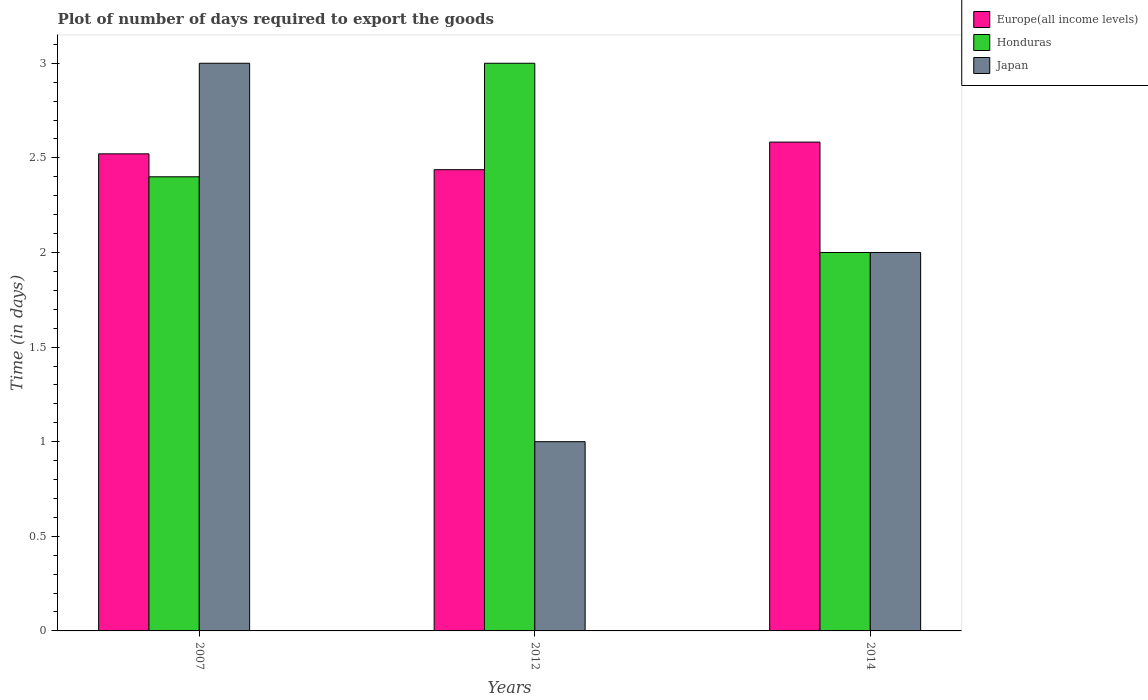How many different coloured bars are there?
Your response must be concise. 3. How many groups of bars are there?
Keep it short and to the point. 3. Are the number of bars per tick equal to the number of legend labels?
Your answer should be compact. Yes. How many bars are there on the 1st tick from the left?
Offer a very short reply. 3. How many bars are there on the 3rd tick from the right?
Offer a terse response. 3. What is the label of the 2nd group of bars from the left?
Offer a terse response. 2012. In how many cases, is the number of bars for a given year not equal to the number of legend labels?
Your answer should be compact. 0. What is the time required to export goods in Japan in 2007?
Offer a very short reply. 3. Across all years, what is the minimum time required to export goods in Japan?
Your answer should be very brief. 1. What is the total time required to export goods in Europe(all income levels) in the graph?
Your answer should be compact. 7.54. What is the difference between the time required to export goods in Japan in 2012 and that in 2014?
Offer a very short reply. -1. In the year 2012, what is the difference between the time required to export goods in Europe(all income levels) and time required to export goods in Honduras?
Your answer should be compact. -0.56. What is the difference between the highest and the second highest time required to export goods in Europe(all income levels)?
Your response must be concise. 0.06. Is the sum of the time required to export goods in Japan in 2012 and 2014 greater than the maximum time required to export goods in Europe(all income levels) across all years?
Provide a short and direct response. Yes. What does the 1st bar from the left in 2007 represents?
Your answer should be compact. Europe(all income levels). What does the 3rd bar from the right in 2012 represents?
Your answer should be compact. Europe(all income levels). Is it the case that in every year, the sum of the time required to export goods in Europe(all income levels) and time required to export goods in Honduras is greater than the time required to export goods in Japan?
Your response must be concise. Yes. How many years are there in the graph?
Offer a terse response. 3. Are the values on the major ticks of Y-axis written in scientific E-notation?
Provide a short and direct response. No. Does the graph contain any zero values?
Ensure brevity in your answer.  No. Does the graph contain grids?
Give a very brief answer. No. How are the legend labels stacked?
Offer a very short reply. Vertical. What is the title of the graph?
Make the answer very short. Plot of number of days required to export the goods. Does "Ecuador" appear as one of the legend labels in the graph?
Offer a terse response. No. What is the label or title of the X-axis?
Your answer should be very brief. Years. What is the label or title of the Y-axis?
Your answer should be very brief. Time (in days). What is the Time (in days) in Europe(all income levels) in 2007?
Offer a terse response. 2.52. What is the Time (in days) in Japan in 2007?
Your answer should be very brief. 3. What is the Time (in days) of Europe(all income levels) in 2012?
Your response must be concise. 2.44. What is the Time (in days) in Honduras in 2012?
Your response must be concise. 3. What is the Time (in days) in Japan in 2012?
Your response must be concise. 1. What is the Time (in days) in Europe(all income levels) in 2014?
Provide a short and direct response. 2.58. Across all years, what is the maximum Time (in days) in Europe(all income levels)?
Give a very brief answer. 2.58. Across all years, what is the minimum Time (in days) in Europe(all income levels)?
Your response must be concise. 2.44. What is the total Time (in days) in Europe(all income levels) in the graph?
Ensure brevity in your answer.  7.54. What is the difference between the Time (in days) of Europe(all income levels) in 2007 and that in 2012?
Offer a terse response. 0.08. What is the difference between the Time (in days) in Honduras in 2007 and that in 2012?
Make the answer very short. -0.6. What is the difference between the Time (in days) in Japan in 2007 and that in 2012?
Offer a terse response. 2. What is the difference between the Time (in days) in Europe(all income levels) in 2007 and that in 2014?
Ensure brevity in your answer.  -0.06. What is the difference between the Time (in days) of Japan in 2007 and that in 2014?
Keep it short and to the point. 1. What is the difference between the Time (in days) in Europe(all income levels) in 2012 and that in 2014?
Offer a terse response. -0.15. What is the difference between the Time (in days) in Japan in 2012 and that in 2014?
Offer a very short reply. -1. What is the difference between the Time (in days) in Europe(all income levels) in 2007 and the Time (in days) in Honduras in 2012?
Offer a very short reply. -0.48. What is the difference between the Time (in days) in Europe(all income levels) in 2007 and the Time (in days) in Japan in 2012?
Offer a terse response. 1.52. What is the difference between the Time (in days) of Europe(all income levels) in 2007 and the Time (in days) of Honduras in 2014?
Offer a very short reply. 0.52. What is the difference between the Time (in days) of Europe(all income levels) in 2007 and the Time (in days) of Japan in 2014?
Keep it short and to the point. 0.52. What is the difference between the Time (in days) of Honduras in 2007 and the Time (in days) of Japan in 2014?
Ensure brevity in your answer.  0.4. What is the difference between the Time (in days) in Europe(all income levels) in 2012 and the Time (in days) in Honduras in 2014?
Give a very brief answer. 0.44. What is the difference between the Time (in days) in Europe(all income levels) in 2012 and the Time (in days) in Japan in 2014?
Keep it short and to the point. 0.44. What is the difference between the Time (in days) in Honduras in 2012 and the Time (in days) in Japan in 2014?
Make the answer very short. 1. What is the average Time (in days) of Europe(all income levels) per year?
Make the answer very short. 2.51. What is the average Time (in days) in Honduras per year?
Make the answer very short. 2.47. What is the average Time (in days) of Japan per year?
Your response must be concise. 2. In the year 2007, what is the difference between the Time (in days) in Europe(all income levels) and Time (in days) in Honduras?
Keep it short and to the point. 0.12. In the year 2007, what is the difference between the Time (in days) in Europe(all income levels) and Time (in days) in Japan?
Your answer should be very brief. -0.48. In the year 2007, what is the difference between the Time (in days) of Honduras and Time (in days) of Japan?
Keep it short and to the point. -0.6. In the year 2012, what is the difference between the Time (in days) in Europe(all income levels) and Time (in days) in Honduras?
Your response must be concise. -0.56. In the year 2012, what is the difference between the Time (in days) of Europe(all income levels) and Time (in days) of Japan?
Offer a terse response. 1.44. In the year 2012, what is the difference between the Time (in days) in Honduras and Time (in days) in Japan?
Your response must be concise. 2. In the year 2014, what is the difference between the Time (in days) of Europe(all income levels) and Time (in days) of Honduras?
Offer a very short reply. 0.58. In the year 2014, what is the difference between the Time (in days) in Europe(all income levels) and Time (in days) in Japan?
Give a very brief answer. 0.58. In the year 2014, what is the difference between the Time (in days) of Honduras and Time (in days) of Japan?
Offer a terse response. 0. What is the ratio of the Time (in days) of Europe(all income levels) in 2007 to that in 2012?
Provide a short and direct response. 1.03. What is the ratio of the Time (in days) of Europe(all income levels) in 2007 to that in 2014?
Your response must be concise. 0.98. What is the ratio of the Time (in days) in Japan in 2007 to that in 2014?
Offer a very short reply. 1.5. What is the ratio of the Time (in days) in Europe(all income levels) in 2012 to that in 2014?
Offer a terse response. 0.94. What is the ratio of the Time (in days) of Honduras in 2012 to that in 2014?
Your answer should be very brief. 1.5. What is the ratio of the Time (in days) in Japan in 2012 to that in 2014?
Offer a terse response. 0.5. What is the difference between the highest and the second highest Time (in days) in Europe(all income levels)?
Ensure brevity in your answer.  0.06. What is the difference between the highest and the second highest Time (in days) of Honduras?
Provide a succinct answer. 0.6. What is the difference between the highest and the lowest Time (in days) of Europe(all income levels)?
Provide a succinct answer. 0.15. 